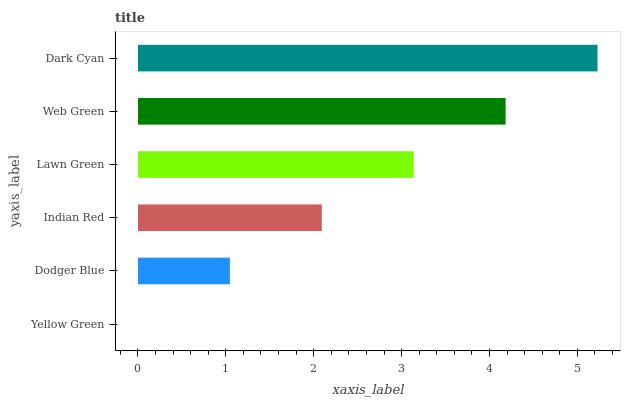Is Yellow Green the minimum?
Answer yes or no. Yes. Is Dark Cyan the maximum?
Answer yes or no. Yes. Is Dodger Blue the minimum?
Answer yes or no. No. Is Dodger Blue the maximum?
Answer yes or no. No. Is Dodger Blue greater than Yellow Green?
Answer yes or no. Yes. Is Yellow Green less than Dodger Blue?
Answer yes or no. Yes. Is Yellow Green greater than Dodger Blue?
Answer yes or no. No. Is Dodger Blue less than Yellow Green?
Answer yes or no. No. Is Lawn Green the high median?
Answer yes or no. Yes. Is Indian Red the low median?
Answer yes or no. Yes. Is Yellow Green the high median?
Answer yes or no. No. Is Dark Cyan the low median?
Answer yes or no. No. 